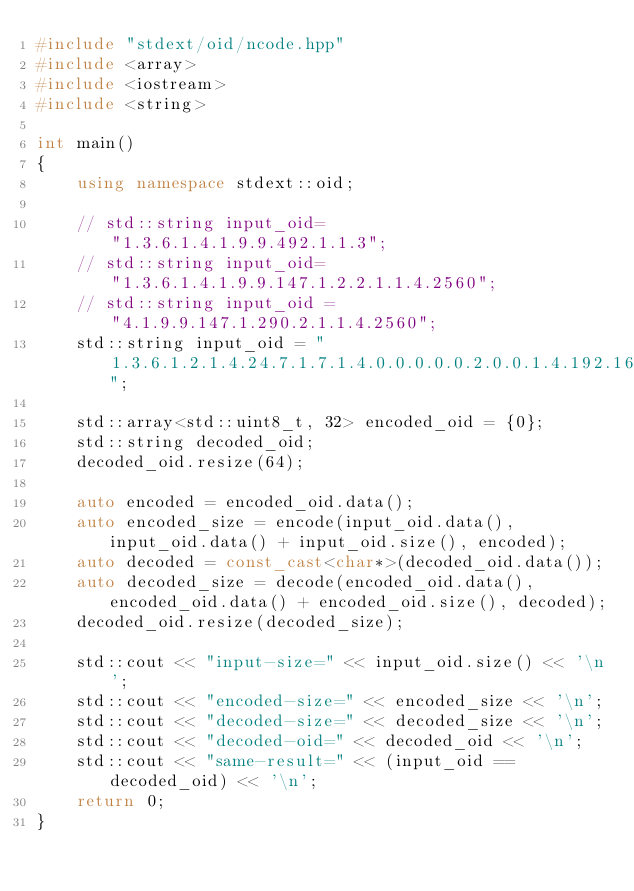Convert code to text. <code><loc_0><loc_0><loc_500><loc_500><_C++_>#include "stdext/oid/ncode.hpp"
#include <array>
#include <iostream>
#include <string>

int main()
{
    using namespace stdext::oid;

    // std::string input_oid= "1.3.6.1.4.1.9.9.492.1.1.3";
    // std::string input_oid= "1.3.6.1.4.1.9.9.147.1.2.2.1.1.4.2560";
    // std::string input_oid = "4.1.9.9.147.1.290.2.1.1.4.2560";
    std::string input_oid = "1.3.6.1.2.1.4.24.7.1.7.1.4.0.0.0.0.0.2.0.0.1.4.192.168.1.1";

    std::array<std::uint8_t, 32> encoded_oid = {0};
    std::string decoded_oid;
    decoded_oid.resize(64);

    auto encoded = encoded_oid.data();
    auto encoded_size = encode(input_oid.data(), input_oid.data() + input_oid.size(), encoded);
    auto decoded = const_cast<char*>(decoded_oid.data());
    auto decoded_size = decode(encoded_oid.data(), encoded_oid.data() + encoded_oid.size(), decoded);
    decoded_oid.resize(decoded_size);

    std::cout << "input-size=" << input_oid.size() << '\n';
    std::cout << "encoded-size=" << encoded_size << '\n';
    std::cout << "decoded-size=" << decoded_size << '\n';
    std::cout << "decoded-oid=" << decoded_oid << '\n';
    std::cout << "same-result=" << (input_oid == decoded_oid) << '\n';
    return 0;
}
</code> 